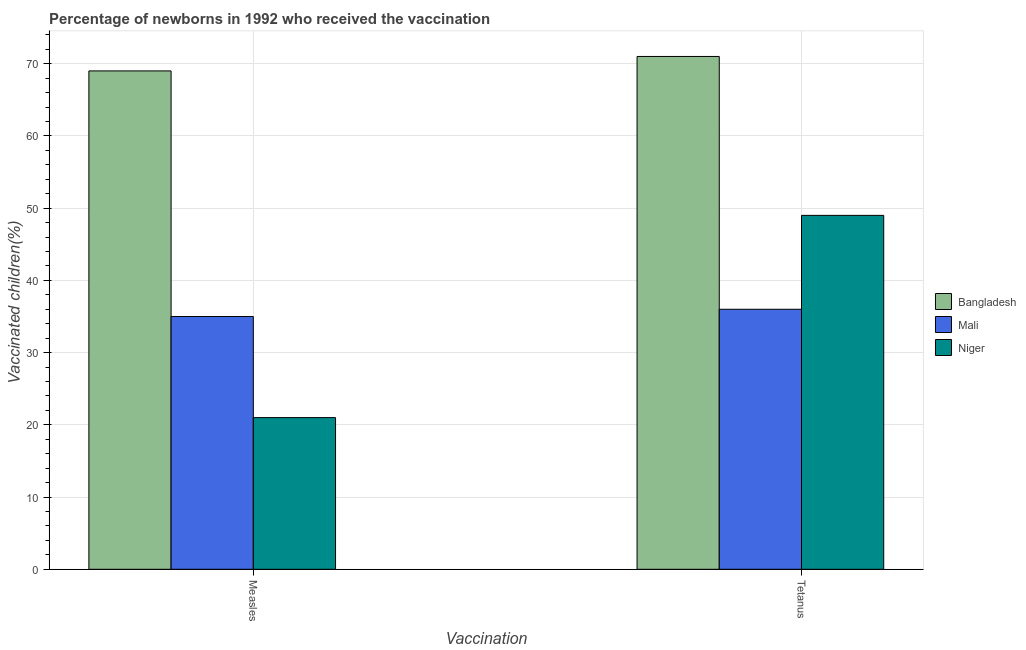How many different coloured bars are there?
Your answer should be very brief. 3. How many groups of bars are there?
Make the answer very short. 2. What is the label of the 1st group of bars from the left?
Give a very brief answer. Measles. What is the percentage of newborns who received vaccination for measles in Bangladesh?
Make the answer very short. 69. Across all countries, what is the maximum percentage of newborns who received vaccination for measles?
Keep it short and to the point. 69. Across all countries, what is the minimum percentage of newborns who received vaccination for tetanus?
Keep it short and to the point. 36. In which country was the percentage of newborns who received vaccination for measles minimum?
Offer a terse response. Niger. What is the total percentage of newborns who received vaccination for tetanus in the graph?
Offer a terse response. 156. What is the difference between the percentage of newborns who received vaccination for tetanus in Niger and that in Mali?
Your response must be concise. 13. What is the difference between the percentage of newborns who received vaccination for tetanus in Bangladesh and the percentage of newborns who received vaccination for measles in Niger?
Give a very brief answer. 50. What is the average percentage of newborns who received vaccination for measles per country?
Give a very brief answer. 41.67. What is the difference between the percentage of newborns who received vaccination for measles and percentage of newborns who received vaccination for tetanus in Bangladesh?
Provide a short and direct response. -2. In how many countries, is the percentage of newborns who received vaccination for measles greater than 26 %?
Ensure brevity in your answer.  2. What is the ratio of the percentage of newborns who received vaccination for measles in Bangladesh to that in Mali?
Offer a very short reply. 1.97. Is the percentage of newborns who received vaccination for measles in Niger less than that in Bangladesh?
Your answer should be very brief. Yes. What does the 2nd bar from the left in Measles represents?
Your answer should be compact. Mali. What does the 1st bar from the right in Measles represents?
Your answer should be compact. Niger. How many bars are there?
Your answer should be very brief. 6. Are all the bars in the graph horizontal?
Make the answer very short. No. Are the values on the major ticks of Y-axis written in scientific E-notation?
Your answer should be compact. No. Does the graph contain any zero values?
Make the answer very short. No. Does the graph contain grids?
Ensure brevity in your answer.  Yes. Where does the legend appear in the graph?
Ensure brevity in your answer.  Center right. How many legend labels are there?
Your answer should be compact. 3. How are the legend labels stacked?
Give a very brief answer. Vertical. What is the title of the graph?
Provide a succinct answer. Percentage of newborns in 1992 who received the vaccination. Does "Finland" appear as one of the legend labels in the graph?
Provide a short and direct response. No. What is the label or title of the X-axis?
Ensure brevity in your answer.  Vaccination. What is the label or title of the Y-axis?
Ensure brevity in your answer.  Vaccinated children(%)
. What is the Vaccinated children(%)
 of Mali in Measles?
Give a very brief answer. 35. What is the Vaccinated children(%)
 in Niger in Measles?
Your response must be concise. 21. What is the Vaccinated children(%)
 of Bangladesh in Tetanus?
Keep it short and to the point. 71. What is the Vaccinated children(%)
 in Mali in Tetanus?
Your answer should be very brief. 36. Across all Vaccination, what is the maximum Vaccinated children(%)
 of Bangladesh?
Ensure brevity in your answer.  71. Across all Vaccination, what is the maximum Vaccinated children(%)
 in Niger?
Your answer should be compact. 49. Across all Vaccination, what is the minimum Vaccinated children(%)
 of Bangladesh?
Offer a very short reply. 69. Across all Vaccination, what is the minimum Vaccinated children(%)
 in Mali?
Provide a short and direct response. 35. Across all Vaccination, what is the minimum Vaccinated children(%)
 of Niger?
Ensure brevity in your answer.  21. What is the total Vaccinated children(%)
 of Bangladesh in the graph?
Provide a succinct answer. 140. What is the total Vaccinated children(%)
 of Niger in the graph?
Provide a succinct answer. 70. What is the difference between the Vaccinated children(%)
 of Bangladesh in Measles and that in Tetanus?
Keep it short and to the point. -2. What is the difference between the Vaccinated children(%)
 in Mali in Measles and that in Tetanus?
Your answer should be compact. -1. What is the difference between the Vaccinated children(%)
 of Bangladesh in Measles and the Vaccinated children(%)
 of Mali in Tetanus?
Ensure brevity in your answer.  33. What is the average Vaccinated children(%)
 in Bangladesh per Vaccination?
Keep it short and to the point. 70. What is the average Vaccinated children(%)
 of Mali per Vaccination?
Your response must be concise. 35.5. What is the average Vaccinated children(%)
 in Niger per Vaccination?
Make the answer very short. 35. What is the difference between the Vaccinated children(%)
 of Bangladesh and Vaccinated children(%)
 of Mali in Measles?
Keep it short and to the point. 34. What is the difference between the Vaccinated children(%)
 of Bangladesh and Vaccinated children(%)
 of Niger in Measles?
Give a very brief answer. 48. What is the difference between the Vaccinated children(%)
 in Bangladesh and Vaccinated children(%)
 in Mali in Tetanus?
Provide a short and direct response. 35. What is the difference between the Vaccinated children(%)
 in Bangladesh and Vaccinated children(%)
 in Niger in Tetanus?
Make the answer very short. 22. What is the difference between the Vaccinated children(%)
 in Mali and Vaccinated children(%)
 in Niger in Tetanus?
Offer a terse response. -13. What is the ratio of the Vaccinated children(%)
 of Bangladesh in Measles to that in Tetanus?
Ensure brevity in your answer.  0.97. What is the ratio of the Vaccinated children(%)
 in Mali in Measles to that in Tetanus?
Keep it short and to the point. 0.97. What is the ratio of the Vaccinated children(%)
 in Niger in Measles to that in Tetanus?
Your answer should be very brief. 0.43. What is the difference between the highest and the second highest Vaccinated children(%)
 of Mali?
Offer a very short reply. 1. What is the difference between the highest and the second highest Vaccinated children(%)
 in Niger?
Give a very brief answer. 28. What is the difference between the highest and the lowest Vaccinated children(%)
 of Mali?
Provide a short and direct response. 1. What is the difference between the highest and the lowest Vaccinated children(%)
 of Niger?
Your response must be concise. 28. 